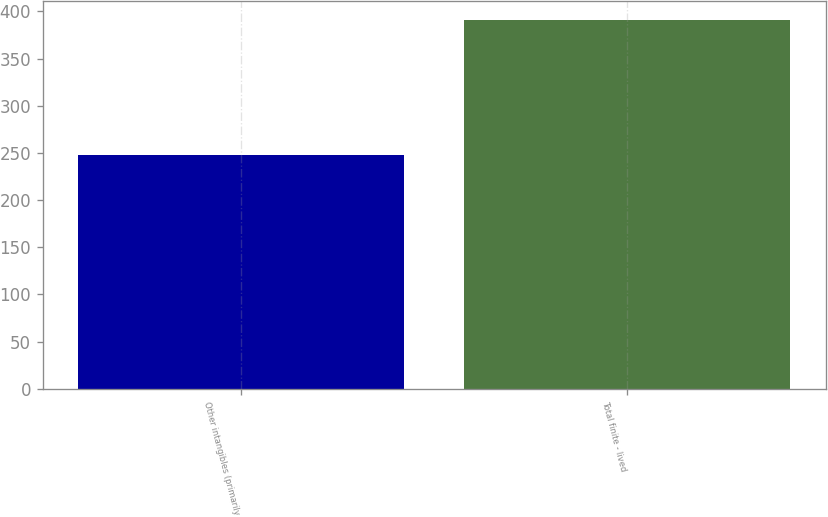Convert chart to OTSL. <chart><loc_0><loc_0><loc_500><loc_500><bar_chart><fcel>Other intangibles (primarily<fcel>Total finite - lived<nl><fcel>248<fcel>391<nl></chart> 